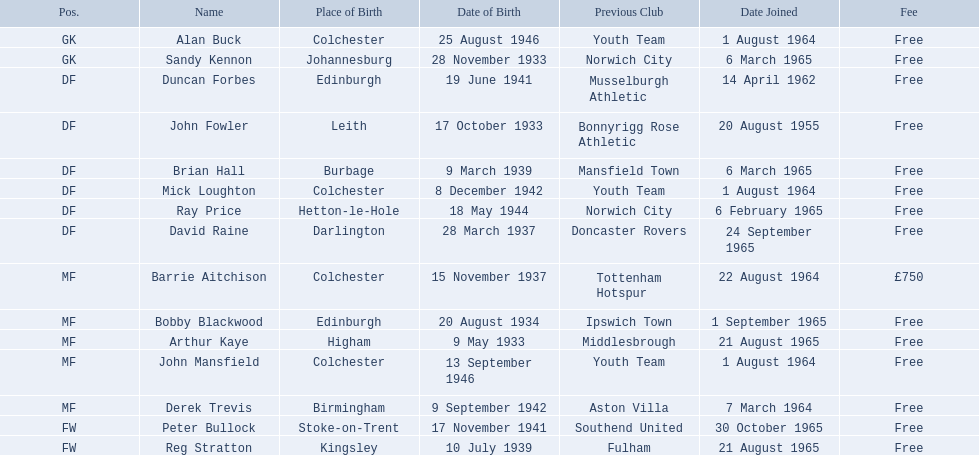When did alan buck join colchester united f.c. in the 1965-66 season? 1 August 1964. When did the last player of that season become a member? Peter Bullock. What was the date when the first player joined the team? 20 August 1955. 